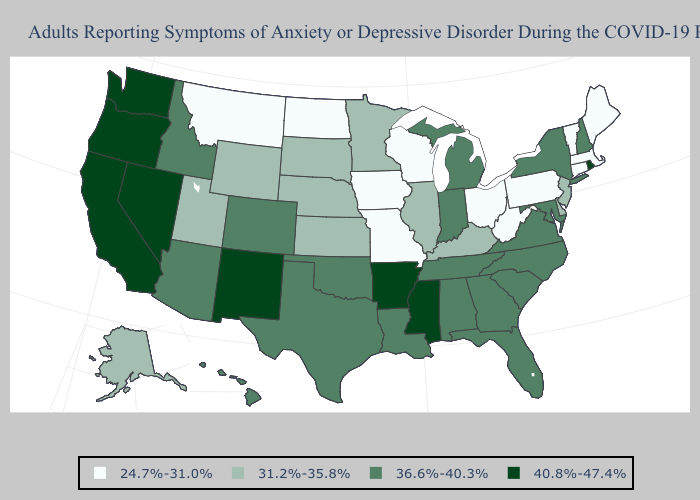Does the first symbol in the legend represent the smallest category?
Answer briefly. Yes. Does the map have missing data?
Short answer required. No. Among the states that border Alabama , does Georgia have the lowest value?
Keep it brief. Yes. Name the states that have a value in the range 40.8%-47.4%?
Answer briefly. Arkansas, California, Mississippi, Nevada, New Mexico, Oregon, Rhode Island, Washington. Does Washington have a higher value than Arkansas?
Concise answer only. No. Does the map have missing data?
Concise answer only. No. Name the states that have a value in the range 36.6%-40.3%?
Short answer required. Alabama, Arizona, Colorado, Florida, Georgia, Hawaii, Idaho, Indiana, Louisiana, Maryland, Michigan, New Hampshire, New York, North Carolina, Oklahoma, South Carolina, Tennessee, Texas, Virginia. What is the value of Missouri?
Write a very short answer. 24.7%-31.0%. How many symbols are there in the legend?
Quick response, please. 4. Name the states that have a value in the range 24.7%-31.0%?
Write a very short answer. Connecticut, Iowa, Maine, Massachusetts, Missouri, Montana, North Dakota, Ohio, Pennsylvania, Vermont, West Virginia, Wisconsin. Name the states that have a value in the range 36.6%-40.3%?
Concise answer only. Alabama, Arizona, Colorado, Florida, Georgia, Hawaii, Idaho, Indiana, Louisiana, Maryland, Michigan, New Hampshire, New York, North Carolina, Oklahoma, South Carolina, Tennessee, Texas, Virginia. Name the states that have a value in the range 40.8%-47.4%?
Keep it brief. Arkansas, California, Mississippi, Nevada, New Mexico, Oregon, Rhode Island, Washington. Name the states that have a value in the range 36.6%-40.3%?
Give a very brief answer. Alabama, Arizona, Colorado, Florida, Georgia, Hawaii, Idaho, Indiana, Louisiana, Maryland, Michigan, New Hampshire, New York, North Carolina, Oklahoma, South Carolina, Tennessee, Texas, Virginia. 